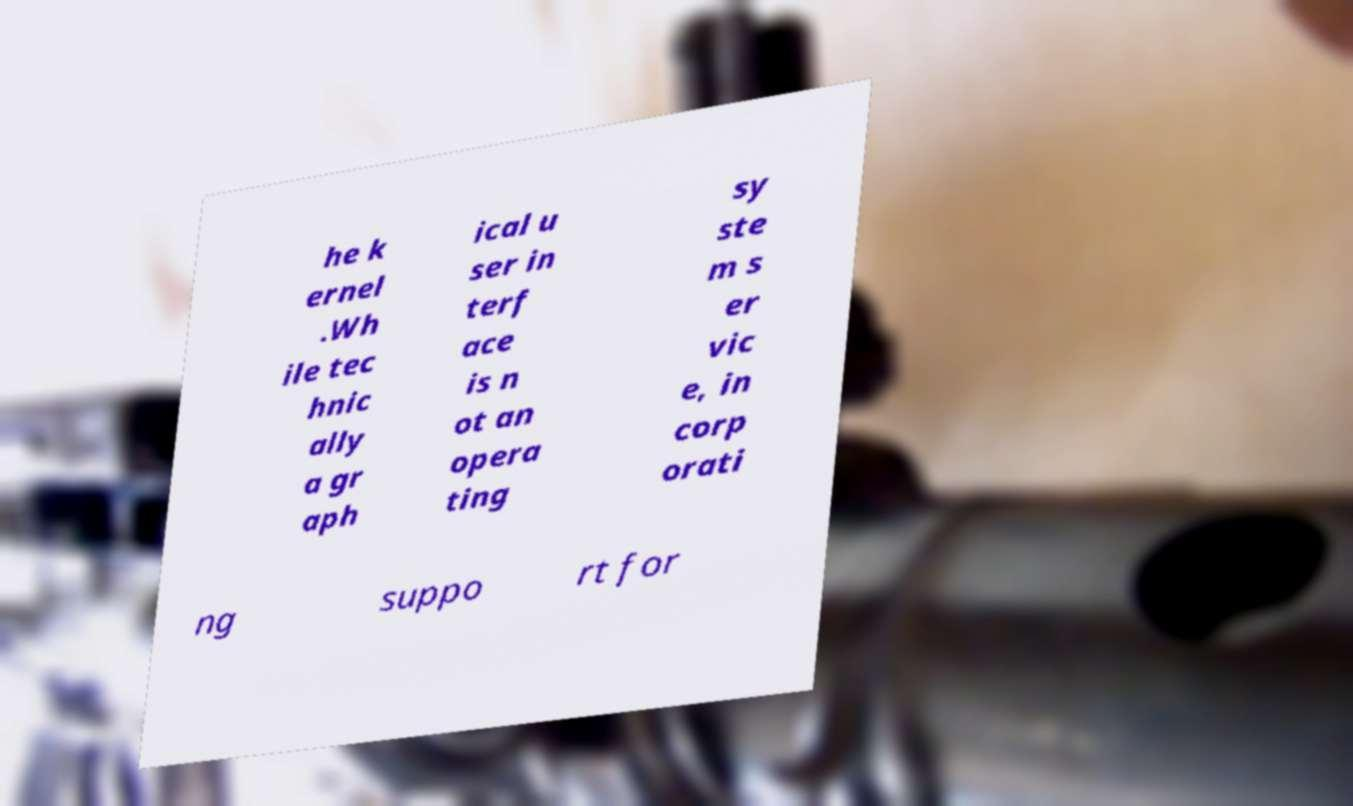What messages or text are displayed in this image? I need them in a readable, typed format. he k ernel .Wh ile tec hnic ally a gr aph ical u ser in terf ace is n ot an opera ting sy ste m s er vic e, in corp orati ng suppo rt for 